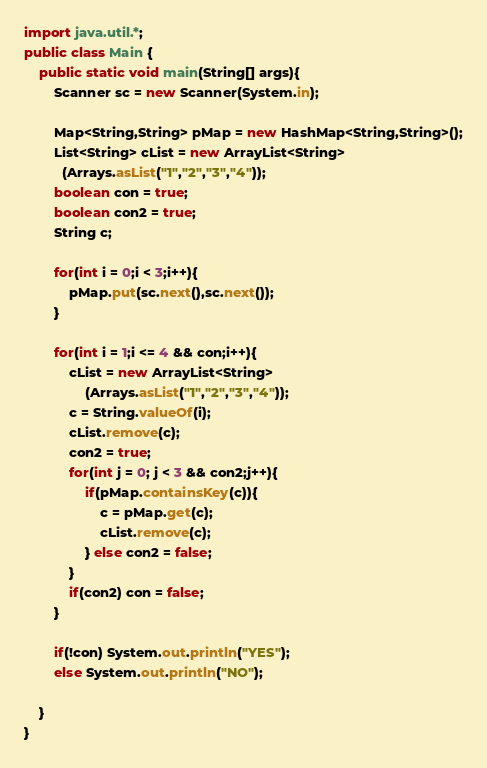Convert code to text. <code><loc_0><loc_0><loc_500><loc_500><_Java_>import java.util.*;
public class Main {
	public static void main(String[] args){
		Scanner sc = new Scanner(System.in);

  		Map<String,String> pMap = new HashMap<String,String>();
      	List<String> cList = new ArrayList<String>
          (Arrays.asList("1","2","3","4"));
      	boolean con = true;
      	boolean con2 = true;
      	String c;
      
      	for(int i = 0;i < 3;i++){
        	pMap.put(sc.next(),sc.next());
        }
      
      	for(int i = 1;i <= 4 && con;i++){
          	cList = new ArrayList<String>
          		(Arrays.asList("1","2","3","4"));
          	c = String.valueOf(i);
          	cList.remove(c);
          	con2 = true;
        	for(int j = 0; j < 3 && con2;j++){
            	if(pMap.containsKey(c)){
                	c = pMap.get(c);
                  	cList.remove(c);
                } else con2 = false;
            }
          	if(con2) con = false;
        }
      	
      	if(!con) System.out.println("YES");
      	else System.out.println("NO");
        
	}
}
</code> 